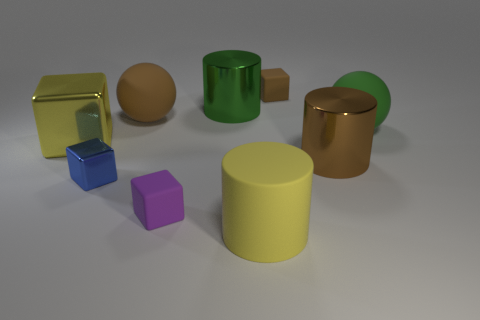There is a big thing on the left side of the brown sphere; is its color the same as the cylinder that is in front of the brown metallic cylinder?
Provide a succinct answer. Yes. What number of matte cylinders are in front of the sphere that is right of the small block right of the big green cylinder?
Your response must be concise. 1. There is a thing that is the same color as the big cube; what size is it?
Give a very brief answer. Large. Is there another block made of the same material as the yellow block?
Make the answer very short. Yes. Is the brown cylinder made of the same material as the green cylinder?
Your answer should be compact. Yes. How many big rubber objects are on the left side of the tiny matte thing that is on the left side of the brown block?
Keep it short and to the point. 1. What number of gray things are either tiny blocks or large spheres?
Provide a short and direct response. 0. What is the shape of the brown rubber object that is behind the large shiny thing that is behind the large yellow object that is to the left of the big green cylinder?
Keep it short and to the point. Cube. The other sphere that is the same size as the brown matte sphere is what color?
Offer a terse response. Green. How many other tiny purple rubber objects have the same shape as the small purple rubber thing?
Offer a terse response. 0. 